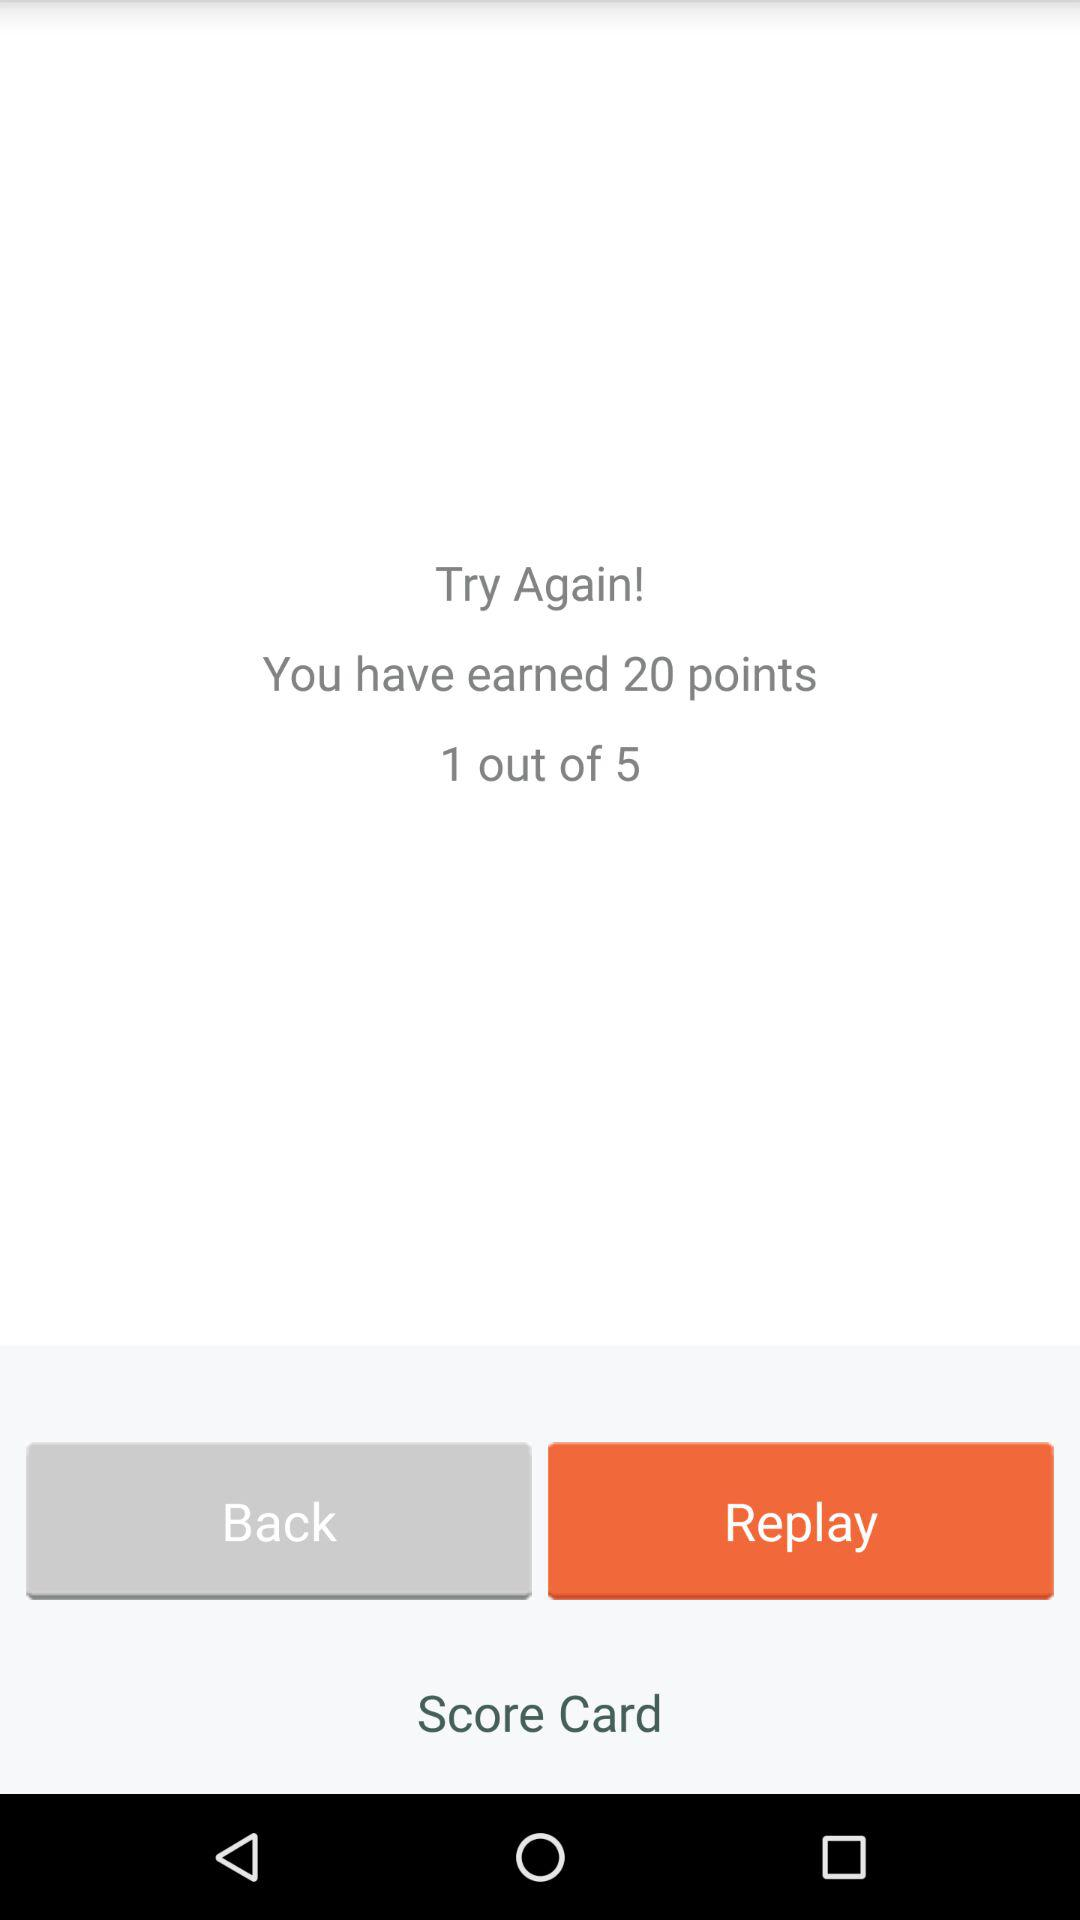How many points have been earned? You have earned 20 points. 